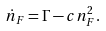Convert formula to latex. <formula><loc_0><loc_0><loc_500><loc_500>\dot { n } _ { F } = \Gamma - c n _ { F } ^ { 2 } .</formula> 